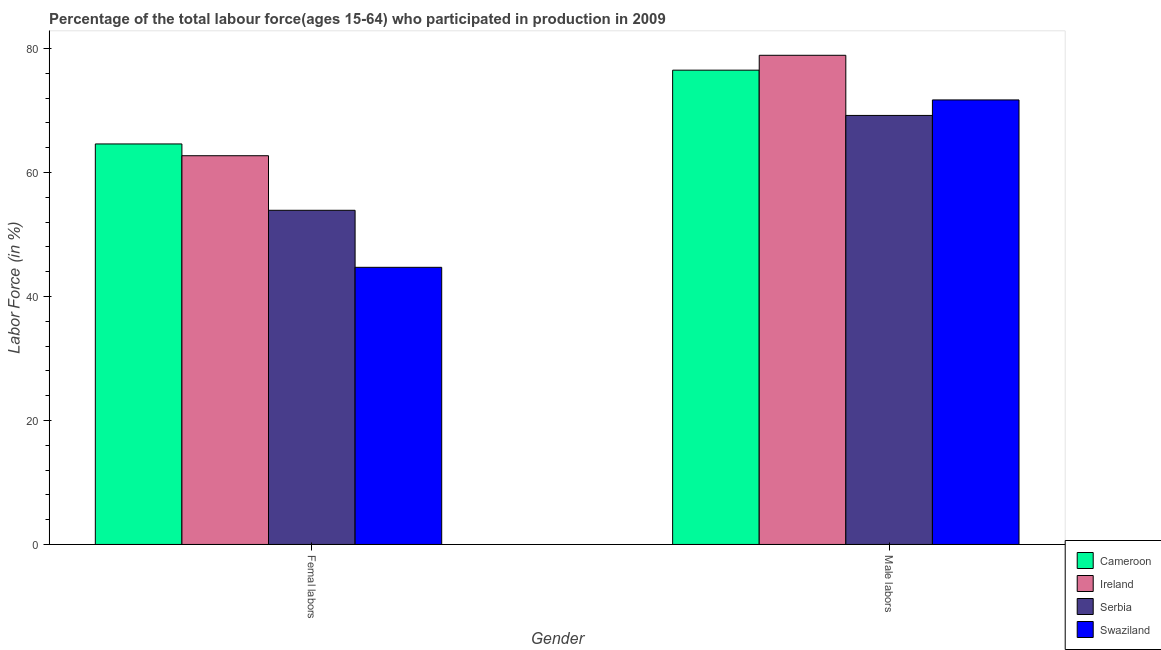How many different coloured bars are there?
Your answer should be very brief. 4. What is the label of the 2nd group of bars from the left?
Your answer should be very brief. Male labors. What is the percentage of male labour force in Cameroon?
Ensure brevity in your answer.  76.5. Across all countries, what is the maximum percentage of female labor force?
Offer a terse response. 64.6. Across all countries, what is the minimum percentage of male labour force?
Your answer should be compact. 69.2. In which country was the percentage of female labor force maximum?
Provide a succinct answer. Cameroon. In which country was the percentage of female labor force minimum?
Your answer should be very brief. Swaziland. What is the total percentage of female labor force in the graph?
Offer a terse response. 225.9. What is the difference between the percentage of male labour force in Swaziland and that in Ireland?
Offer a very short reply. -7.2. What is the difference between the percentage of female labor force in Serbia and the percentage of male labour force in Cameroon?
Your answer should be very brief. -22.6. What is the average percentage of female labor force per country?
Your answer should be very brief. 56.48. What is the difference between the percentage of female labor force and percentage of male labour force in Serbia?
Offer a terse response. -15.3. What is the ratio of the percentage of female labor force in Ireland to that in Serbia?
Make the answer very short. 1.16. Is the percentage of female labor force in Ireland less than that in Serbia?
Provide a short and direct response. No. In how many countries, is the percentage of male labour force greater than the average percentage of male labour force taken over all countries?
Offer a terse response. 2. What does the 1st bar from the left in Femal labors represents?
Provide a succinct answer. Cameroon. What does the 3rd bar from the right in Femal labors represents?
Keep it short and to the point. Ireland. Are all the bars in the graph horizontal?
Give a very brief answer. No. What is the difference between two consecutive major ticks on the Y-axis?
Your response must be concise. 20. How many legend labels are there?
Make the answer very short. 4. What is the title of the graph?
Your answer should be compact. Percentage of the total labour force(ages 15-64) who participated in production in 2009. Does "Italy" appear as one of the legend labels in the graph?
Offer a very short reply. No. What is the label or title of the Y-axis?
Provide a short and direct response. Labor Force (in %). What is the Labor Force (in %) of Cameroon in Femal labors?
Ensure brevity in your answer.  64.6. What is the Labor Force (in %) in Ireland in Femal labors?
Offer a very short reply. 62.7. What is the Labor Force (in %) of Serbia in Femal labors?
Make the answer very short. 53.9. What is the Labor Force (in %) of Swaziland in Femal labors?
Ensure brevity in your answer.  44.7. What is the Labor Force (in %) in Cameroon in Male labors?
Offer a terse response. 76.5. What is the Labor Force (in %) in Ireland in Male labors?
Ensure brevity in your answer.  78.9. What is the Labor Force (in %) of Serbia in Male labors?
Your response must be concise. 69.2. What is the Labor Force (in %) in Swaziland in Male labors?
Keep it short and to the point. 71.7. Across all Gender, what is the maximum Labor Force (in %) of Cameroon?
Offer a very short reply. 76.5. Across all Gender, what is the maximum Labor Force (in %) of Ireland?
Keep it short and to the point. 78.9. Across all Gender, what is the maximum Labor Force (in %) in Serbia?
Your response must be concise. 69.2. Across all Gender, what is the maximum Labor Force (in %) in Swaziland?
Make the answer very short. 71.7. Across all Gender, what is the minimum Labor Force (in %) in Cameroon?
Your answer should be very brief. 64.6. Across all Gender, what is the minimum Labor Force (in %) of Ireland?
Provide a succinct answer. 62.7. Across all Gender, what is the minimum Labor Force (in %) in Serbia?
Make the answer very short. 53.9. Across all Gender, what is the minimum Labor Force (in %) in Swaziland?
Keep it short and to the point. 44.7. What is the total Labor Force (in %) of Cameroon in the graph?
Offer a very short reply. 141.1. What is the total Labor Force (in %) in Ireland in the graph?
Your answer should be very brief. 141.6. What is the total Labor Force (in %) of Serbia in the graph?
Ensure brevity in your answer.  123.1. What is the total Labor Force (in %) in Swaziland in the graph?
Keep it short and to the point. 116.4. What is the difference between the Labor Force (in %) in Ireland in Femal labors and that in Male labors?
Offer a terse response. -16.2. What is the difference between the Labor Force (in %) in Serbia in Femal labors and that in Male labors?
Offer a terse response. -15.3. What is the difference between the Labor Force (in %) in Swaziland in Femal labors and that in Male labors?
Your answer should be very brief. -27. What is the difference between the Labor Force (in %) in Cameroon in Femal labors and the Labor Force (in %) in Ireland in Male labors?
Provide a succinct answer. -14.3. What is the difference between the Labor Force (in %) of Serbia in Femal labors and the Labor Force (in %) of Swaziland in Male labors?
Your answer should be compact. -17.8. What is the average Labor Force (in %) of Cameroon per Gender?
Your response must be concise. 70.55. What is the average Labor Force (in %) of Ireland per Gender?
Your response must be concise. 70.8. What is the average Labor Force (in %) in Serbia per Gender?
Your answer should be very brief. 61.55. What is the average Labor Force (in %) of Swaziland per Gender?
Provide a succinct answer. 58.2. What is the difference between the Labor Force (in %) of Cameroon and Labor Force (in %) of Serbia in Femal labors?
Make the answer very short. 10.7. What is the difference between the Labor Force (in %) of Ireland and Labor Force (in %) of Serbia in Femal labors?
Keep it short and to the point. 8.8. What is the difference between the Labor Force (in %) of Ireland and Labor Force (in %) of Swaziland in Femal labors?
Give a very brief answer. 18. What is the difference between the Labor Force (in %) of Serbia and Labor Force (in %) of Swaziland in Femal labors?
Provide a succinct answer. 9.2. What is the difference between the Labor Force (in %) of Cameroon and Labor Force (in %) of Serbia in Male labors?
Ensure brevity in your answer.  7.3. What is the difference between the Labor Force (in %) of Ireland and Labor Force (in %) of Serbia in Male labors?
Offer a very short reply. 9.7. What is the difference between the Labor Force (in %) of Ireland and Labor Force (in %) of Swaziland in Male labors?
Offer a very short reply. 7.2. What is the difference between the Labor Force (in %) in Serbia and Labor Force (in %) in Swaziland in Male labors?
Your response must be concise. -2.5. What is the ratio of the Labor Force (in %) in Cameroon in Femal labors to that in Male labors?
Ensure brevity in your answer.  0.84. What is the ratio of the Labor Force (in %) in Ireland in Femal labors to that in Male labors?
Your response must be concise. 0.79. What is the ratio of the Labor Force (in %) in Serbia in Femal labors to that in Male labors?
Give a very brief answer. 0.78. What is the ratio of the Labor Force (in %) in Swaziland in Femal labors to that in Male labors?
Offer a terse response. 0.62. What is the difference between the highest and the second highest Labor Force (in %) of Cameroon?
Offer a very short reply. 11.9. What is the difference between the highest and the second highest Labor Force (in %) of Swaziland?
Keep it short and to the point. 27. What is the difference between the highest and the lowest Labor Force (in %) in Serbia?
Offer a terse response. 15.3. What is the difference between the highest and the lowest Labor Force (in %) of Swaziland?
Offer a very short reply. 27. 